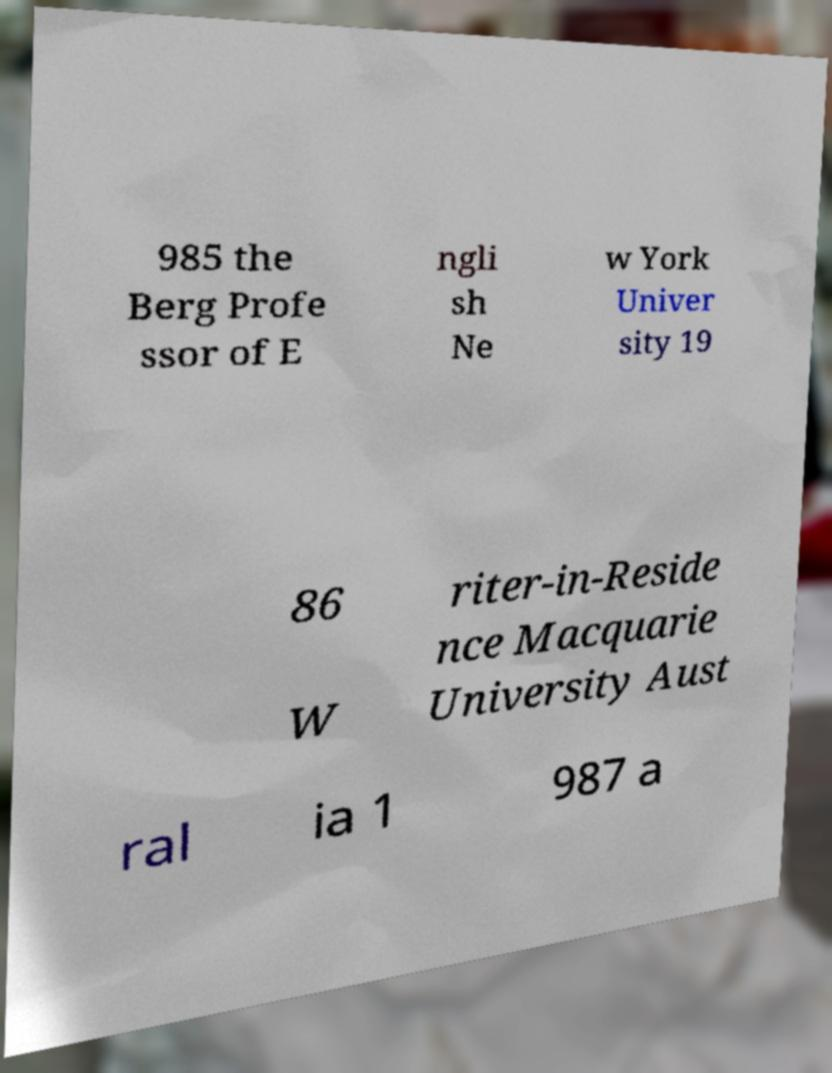Could you extract and type out the text from this image? 985 the Berg Profe ssor of E ngli sh Ne w York Univer sity 19 86 W riter-in-Reside nce Macquarie University Aust ral ia 1 987 a 